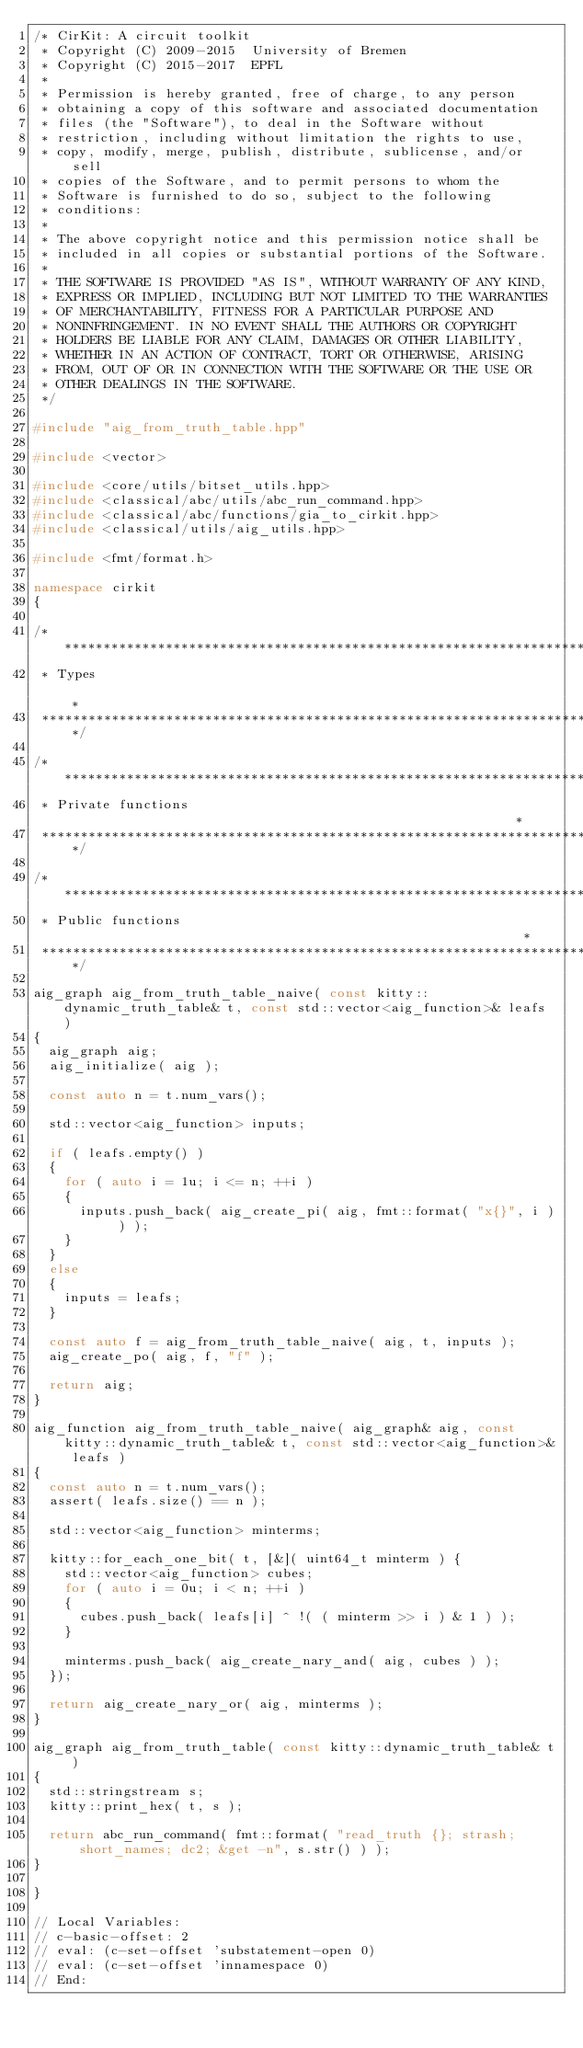Convert code to text. <code><loc_0><loc_0><loc_500><loc_500><_C++_>/* CirKit: A circuit toolkit
 * Copyright (C) 2009-2015  University of Bremen
 * Copyright (C) 2015-2017  EPFL
 *
 * Permission is hereby granted, free of charge, to any person
 * obtaining a copy of this software and associated documentation
 * files (the "Software"), to deal in the Software without
 * restriction, including without limitation the rights to use,
 * copy, modify, merge, publish, distribute, sublicense, and/or sell
 * copies of the Software, and to permit persons to whom the
 * Software is furnished to do so, subject to the following
 * conditions:
 *
 * The above copyright notice and this permission notice shall be
 * included in all copies or substantial portions of the Software.
 *
 * THE SOFTWARE IS PROVIDED "AS IS", WITHOUT WARRANTY OF ANY KIND,
 * EXPRESS OR IMPLIED, INCLUDING BUT NOT LIMITED TO THE WARRANTIES
 * OF MERCHANTABILITY, FITNESS FOR A PARTICULAR PURPOSE AND
 * NONINFRINGEMENT. IN NO EVENT SHALL THE AUTHORS OR COPYRIGHT
 * HOLDERS BE LIABLE FOR ANY CLAIM, DAMAGES OR OTHER LIABILITY,
 * WHETHER IN AN ACTION OF CONTRACT, TORT OR OTHERWISE, ARISING
 * FROM, OUT OF OR IN CONNECTION WITH THE SOFTWARE OR THE USE OR
 * OTHER DEALINGS IN THE SOFTWARE.
 */

#include "aig_from_truth_table.hpp"

#include <vector>

#include <core/utils/bitset_utils.hpp>
#include <classical/abc/utils/abc_run_command.hpp>
#include <classical/abc/functions/gia_to_cirkit.hpp>
#include <classical/utils/aig_utils.hpp>

#include <fmt/format.h>

namespace cirkit
{

/******************************************************************************
 * Types                                                                      *
 ******************************************************************************/

/******************************************************************************
 * Private functions                                                          *
 ******************************************************************************/

/******************************************************************************
 * Public functions                                                           *
 ******************************************************************************/

aig_graph aig_from_truth_table_naive( const kitty::dynamic_truth_table& t, const std::vector<aig_function>& leafs )
{
  aig_graph aig;
  aig_initialize( aig );

  const auto n = t.num_vars();

  std::vector<aig_function> inputs;

  if ( leafs.empty() )
  {
    for ( auto i = 1u; i <= n; ++i )
    {
      inputs.push_back( aig_create_pi( aig, fmt::format( "x{}", i ) ) );
    }
  }
  else
  {
    inputs = leafs;
  }

  const auto f = aig_from_truth_table_naive( aig, t, inputs );
  aig_create_po( aig, f, "f" );

  return aig;
}

aig_function aig_from_truth_table_naive( aig_graph& aig, const kitty::dynamic_truth_table& t, const std::vector<aig_function>& leafs )
{
  const auto n = t.num_vars();
  assert( leafs.size() == n );

  std::vector<aig_function> minterms;

  kitty::for_each_one_bit( t, [&]( uint64_t minterm ) {
    std::vector<aig_function> cubes;
    for ( auto i = 0u; i < n; ++i )
    {
      cubes.push_back( leafs[i] ^ !( ( minterm >> i ) & 1 ) );
    }

    minterms.push_back( aig_create_nary_and( aig, cubes ) );
  });

  return aig_create_nary_or( aig, minterms );
}

aig_graph aig_from_truth_table( const kitty::dynamic_truth_table& t )
{
  std::stringstream s;
  kitty::print_hex( t, s );

  return abc_run_command( fmt::format( "read_truth {}; strash; short_names; dc2; &get -n", s.str() ) );
}

}

// Local Variables:
// c-basic-offset: 2
// eval: (c-set-offset 'substatement-open 0)
// eval: (c-set-offset 'innamespace 0)
// End:
</code> 